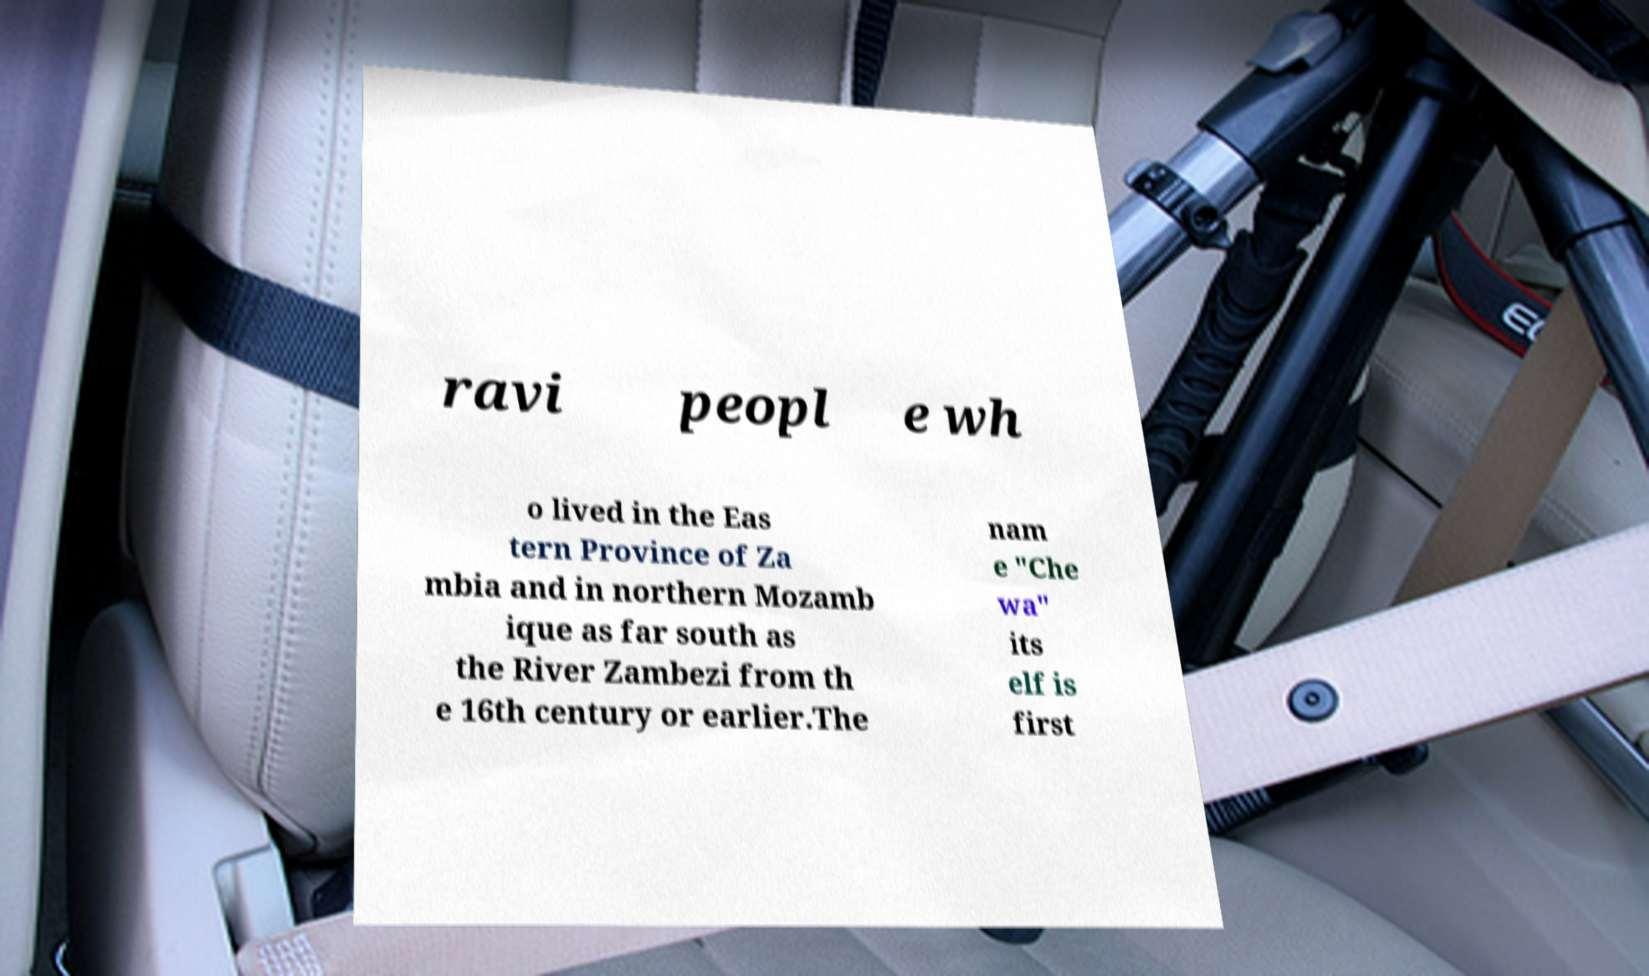I need the written content from this picture converted into text. Can you do that? ravi peopl e wh o lived in the Eas tern Province of Za mbia and in northern Mozamb ique as far south as the River Zambezi from th e 16th century or earlier.The nam e "Che wa" its elf is first 